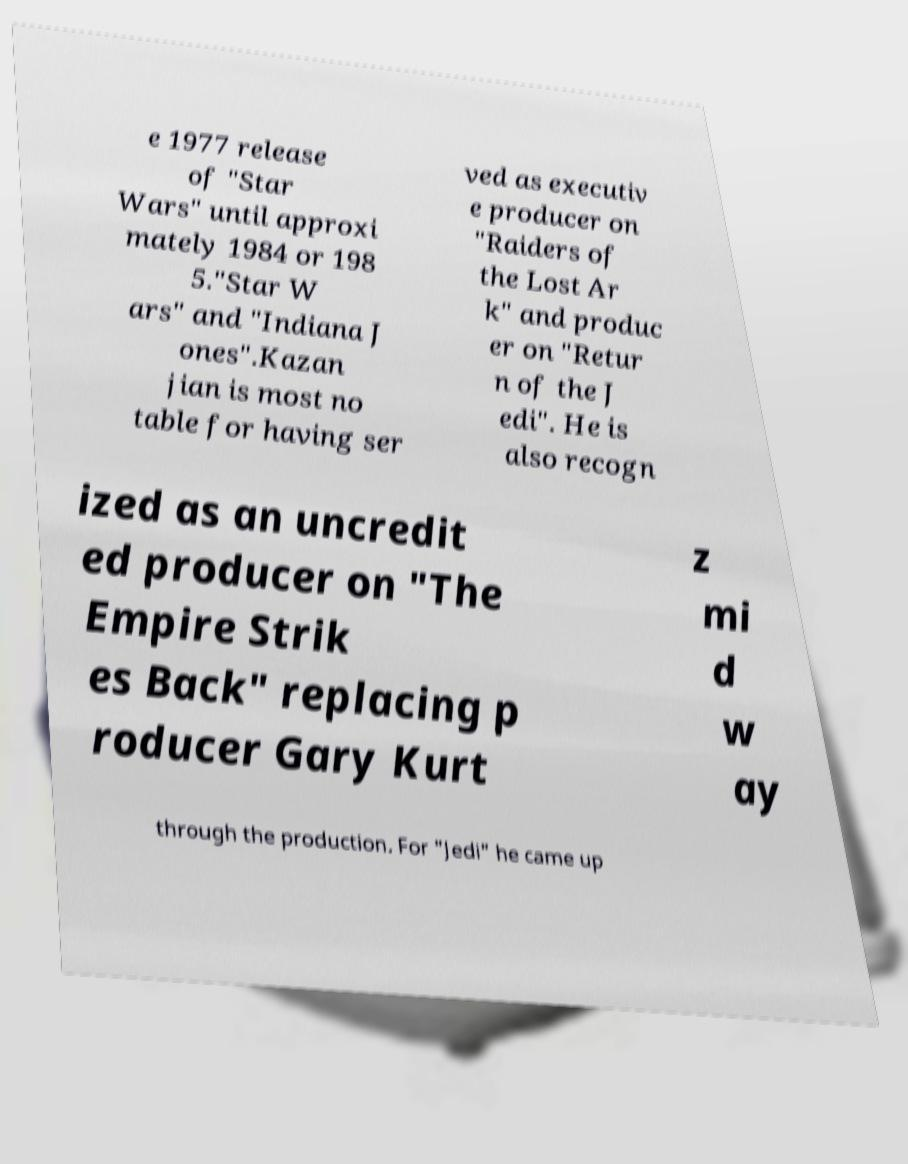Could you assist in decoding the text presented in this image and type it out clearly? e 1977 release of "Star Wars" until approxi mately 1984 or 198 5."Star W ars" and "Indiana J ones".Kazan jian is most no table for having ser ved as executiv e producer on "Raiders of the Lost Ar k" and produc er on "Retur n of the J edi". He is also recogn ized as an uncredit ed producer on "The Empire Strik es Back" replacing p roducer Gary Kurt z mi d w ay through the production. For "Jedi" he came up 